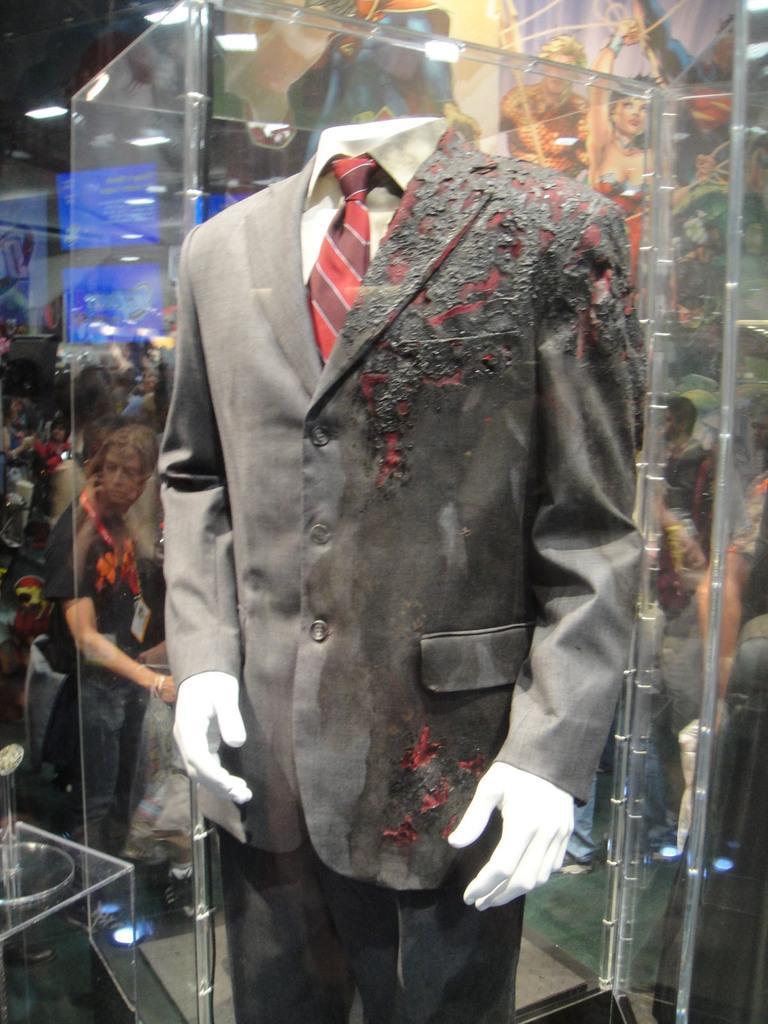Can you describe this image briefly? This image consists of a mannequin on which there is a suit. It is partially burnt. In the background, there are many people. And we can see a red tie. 